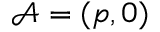Convert formula to latex. <formula><loc_0><loc_0><loc_500><loc_500>\mathcal { A } = ( p , 0 )</formula> 